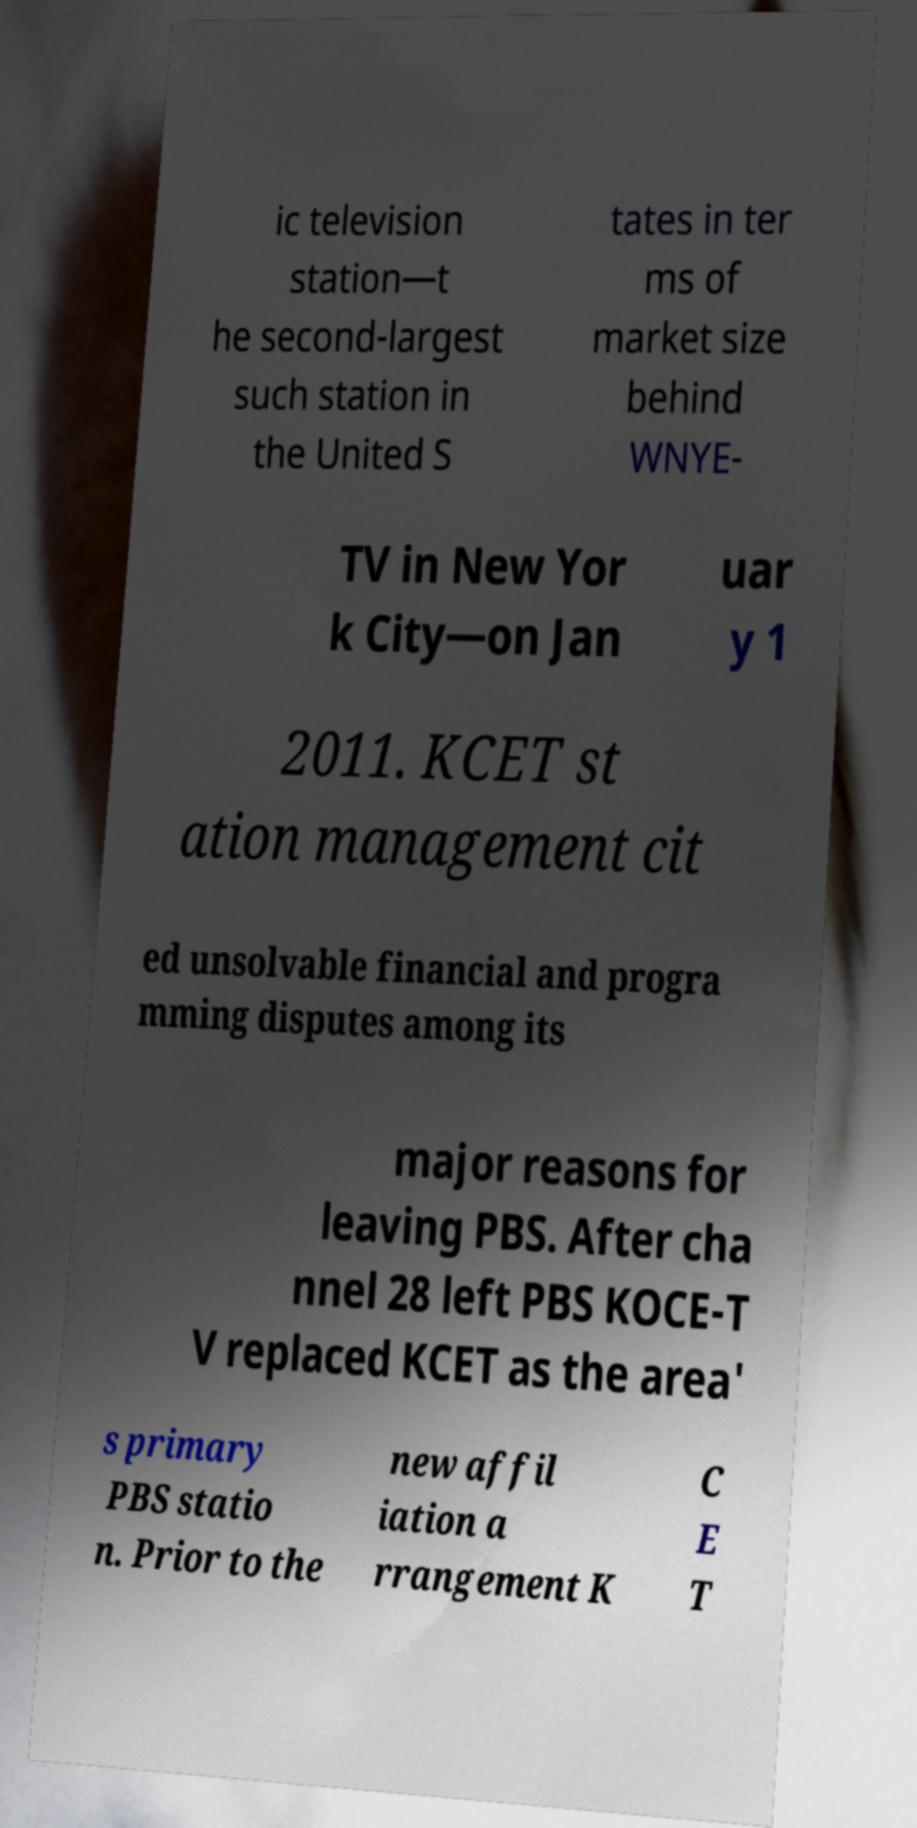Please identify and transcribe the text found in this image. ic television station—t he second-largest such station in the United S tates in ter ms of market size behind WNYE- TV in New Yor k City—on Jan uar y 1 2011. KCET st ation management cit ed unsolvable financial and progra mming disputes among its major reasons for leaving PBS. After cha nnel 28 left PBS KOCE-T V replaced KCET as the area' s primary PBS statio n. Prior to the new affil iation a rrangement K C E T 